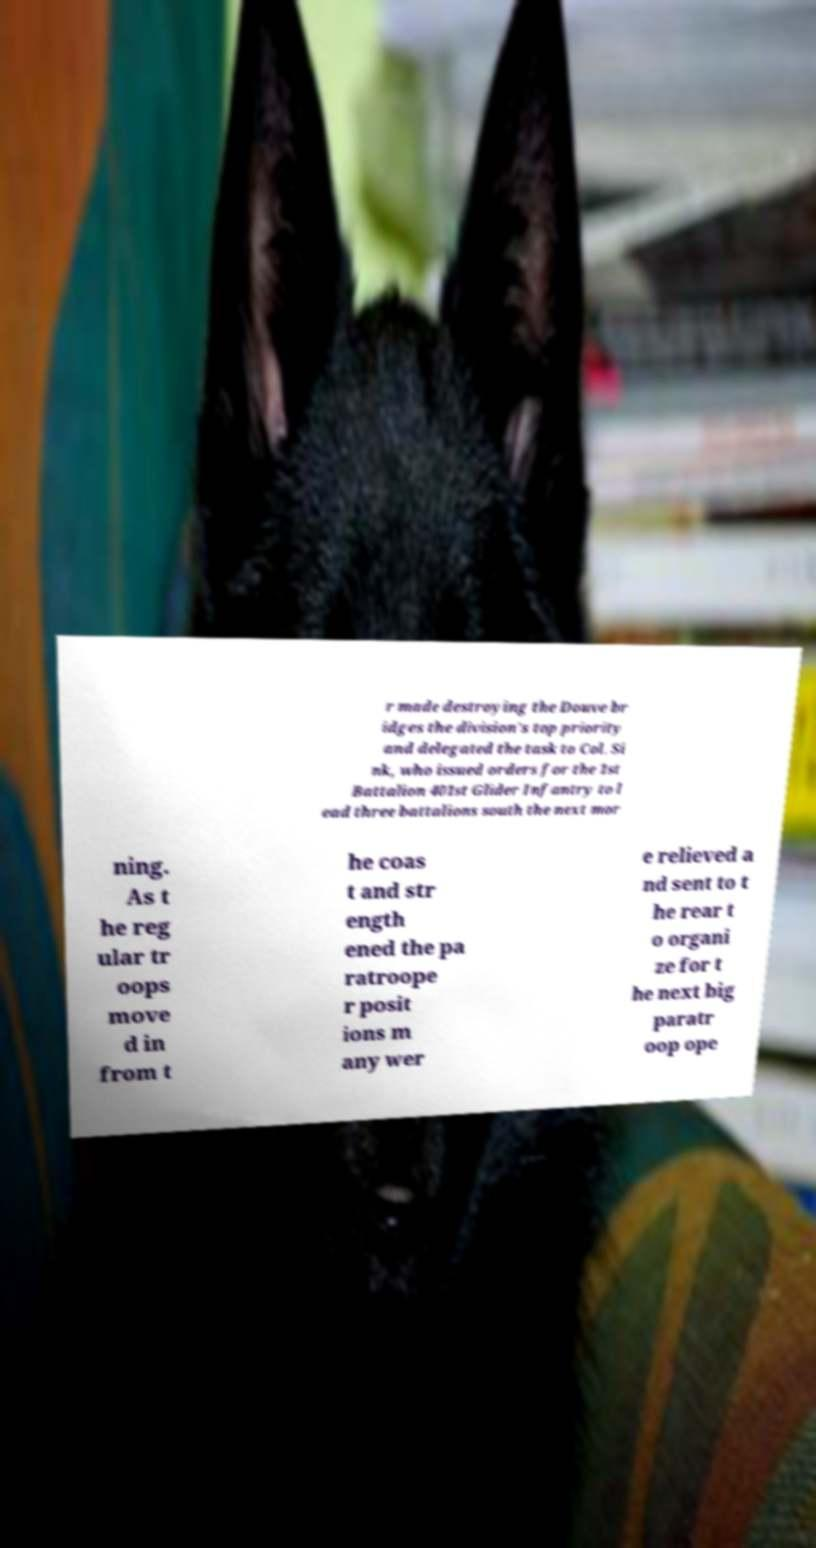What messages or text are displayed in this image? I need them in a readable, typed format. r made destroying the Douve br idges the division's top priority and delegated the task to Col. Si nk, who issued orders for the 1st Battalion 401st Glider Infantry to l ead three battalions south the next mor ning. As t he reg ular tr oops move d in from t he coas t and str ength ened the pa ratroope r posit ions m any wer e relieved a nd sent to t he rear t o organi ze for t he next big paratr oop ope 